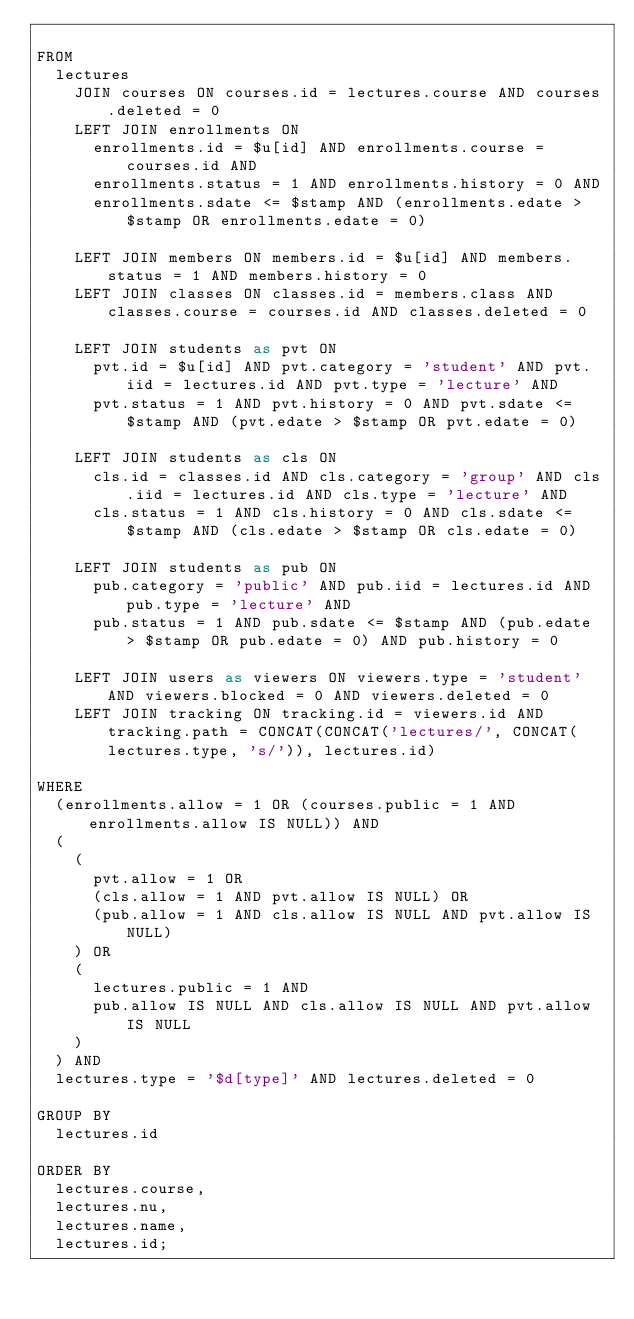Convert code to text. <code><loc_0><loc_0><loc_500><loc_500><_SQL_>
FROM
  lectures
    JOIN courses ON courses.id = lectures.course AND courses.deleted = 0
    LEFT JOIN enrollments ON
      enrollments.id = $u[id] AND enrollments.course = courses.id AND
      enrollments.status = 1 AND enrollments.history = 0 AND
      enrollments.sdate <= $stamp AND (enrollments.edate > $stamp OR enrollments.edate = 0)

    LEFT JOIN members ON members.id = $u[id] AND members.status = 1 AND members.history = 0
    LEFT JOIN classes ON classes.id = members.class AND classes.course = courses.id AND classes.deleted = 0

    LEFT JOIN students as pvt ON
      pvt.id = $u[id] AND pvt.category = 'student' AND pvt.iid = lectures.id AND pvt.type = 'lecture' AND
      pvt.status = 1 AND pvt.history = 0 AND pvt.sdate <= $stamp AND (pvt.edate > $stamp OR pvt.edate = 0)

    LEFT JOIN students as cls ON
      cls.id = classes.id AND cls.category = 'group' AND cls.iid = lectures.id AND cls.type = 'lecture' AND
      cls.status = 1 AND cls.history = 0 AND cls.sdate <= $stamp AND (cls.edate > $stamp OR cls.edate = 0)

    LEFT JOIN students as pub ON
      pub.category = 'public' AND pub.iid = lectures.id AND pub.type = 'lecture' AND
      pub.status = 1 AND pub.sdate <= $stamp AND (pub.edate > $stamp OR pub.edate = 0) AND pub.history = 0

    LEFT JOIN users as viewers ON viewers.type = 'student' AND viewers.blocked = 0 AND viewers.deleted = 0
    LEFT JOIN tracking ON tracking.id = viewers.id AND tracking.path = CONCAT(CONCAT('lectures/', CONCAT(lectures.type, 's/')), lectures.id)

WHERE
  (enrollments.allow = 1 OR (courses.public = 1 AND enrollments.allow IS NULL)) AND
  (
    (
      pvt.allow = 1 OR
      (cls.allow = 1 AND pvt.allow IS NULL) OR
      (pub.allow = 1 AND cls.allow IS NULL AND pvt.allow IS NULL)
    ) OR
    (
      lectures.public = 1 AND
      pub.allow IS NULL AND cls.allow IS NULL AND pvt.allow IS NULL
    )
  ) AND
  lectures.type = '$d[type]' AND lectures.deleted = 0

GROUP BY
  lectures.id
  
ORDER BY
  lectures.course,
  lectures.nu,
  lectures.name,
  lectures.id;</code> 